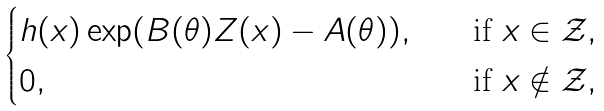<formula> <loc_0><loc_0><loc_500><loc_500>\begin{cases} h ( x ) \exp ( B ( \theta ) Z ( x ) - A ( \theta ) ) , \quad & \text {if } x \in \mathcal { Z } , \\ 0 , & \text {if } x \notin \mathcal { Z } , \end{cases}</formula> 